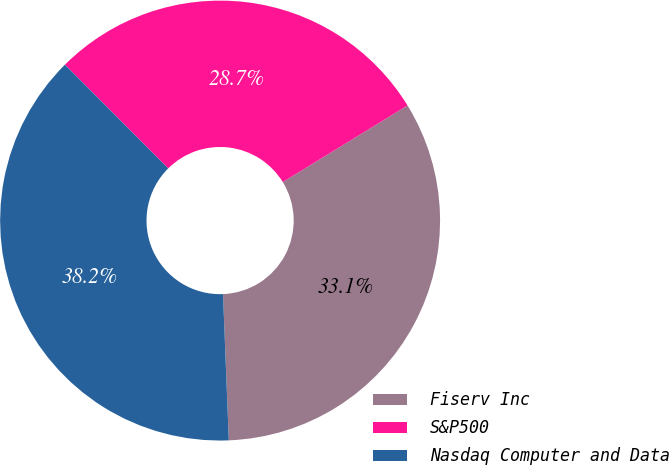<chart> <loc_0><loc_0><loc_500><loc_500><pie_chart><fcel>Fiserv Inc<fcel>S&P500<fcel>Nasdaq Computer and Data<nl><fcel>33.14%<fcel>28.7%<fcel>38.17%<nl></chart> 